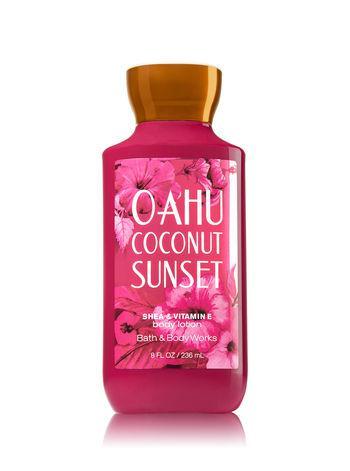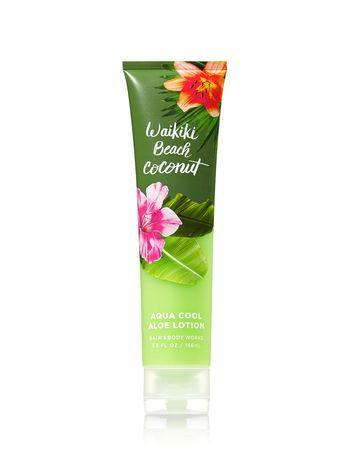The first image is the image on the left, the second image is the image on the right. For the images displayed, is the sentence "The left image shows a bottle of white lotion." factually correct? Answer yes or no. No. The first image is the image on the left, the second image is the image on the right. For the images shown, is this caption "There are exactly two objects standing." true? Answer yes or no. Yes. 